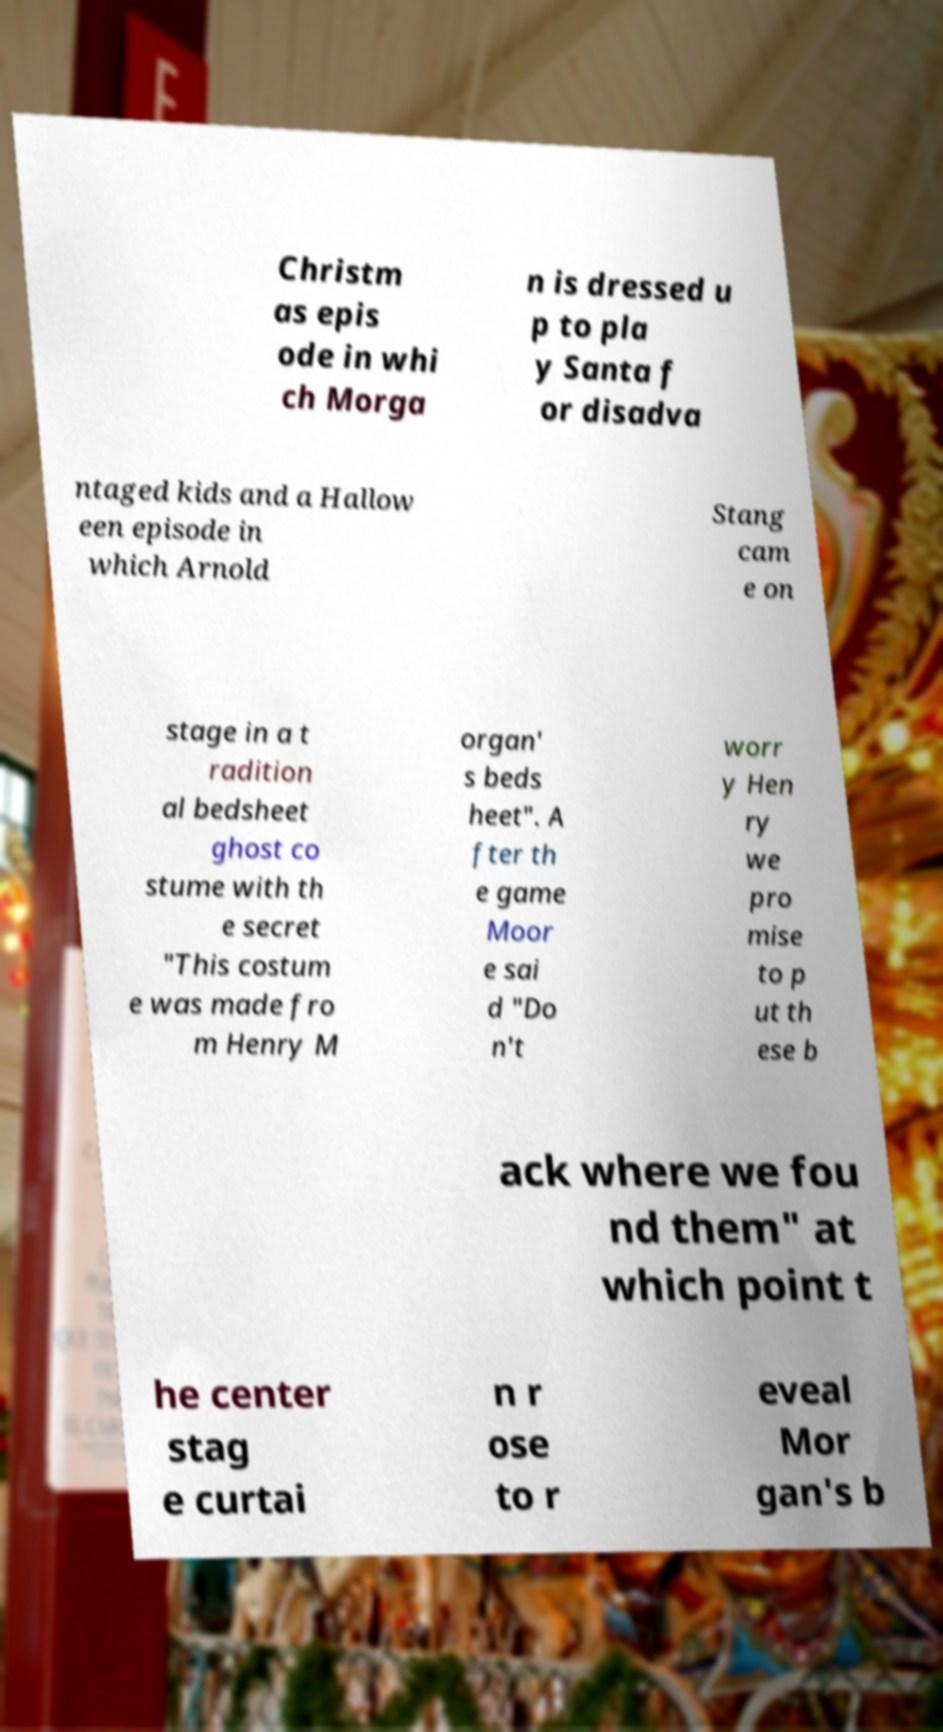Please read and relay the text visible in this image. What does it say? Christm as epis ode in whi ch Morga n is dressed u p to pla y Santa f or disadva ntaged kids and a Hallow een episode in which Arnold Stang cam e on stage in a t radition al bedsheet ghost co stume with th e secret "This costum e was made fro m Henry M organ' s beds heet". A fter th e game Moor e sai d "Do n't worr y Hen ry we pro mise to p ut th ese b ack where we fou nd them" at which point t he center stag e curtai n r ose to r eveal Mor gan's b 